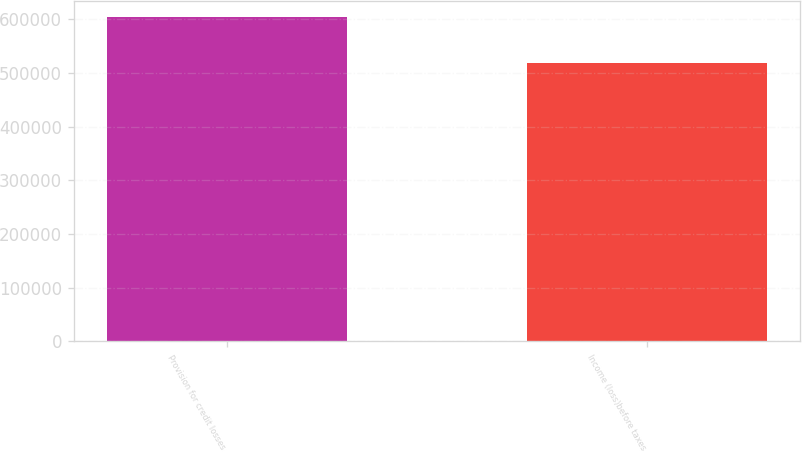Convert chart. <chart><loc_0><loc_0><loc_500><loc_500><bar_chart><fcel>Provision for credit losses<fcel>Income (loss)before taxes<nl><fcel>604000<fcel>519291<nl></chart> 